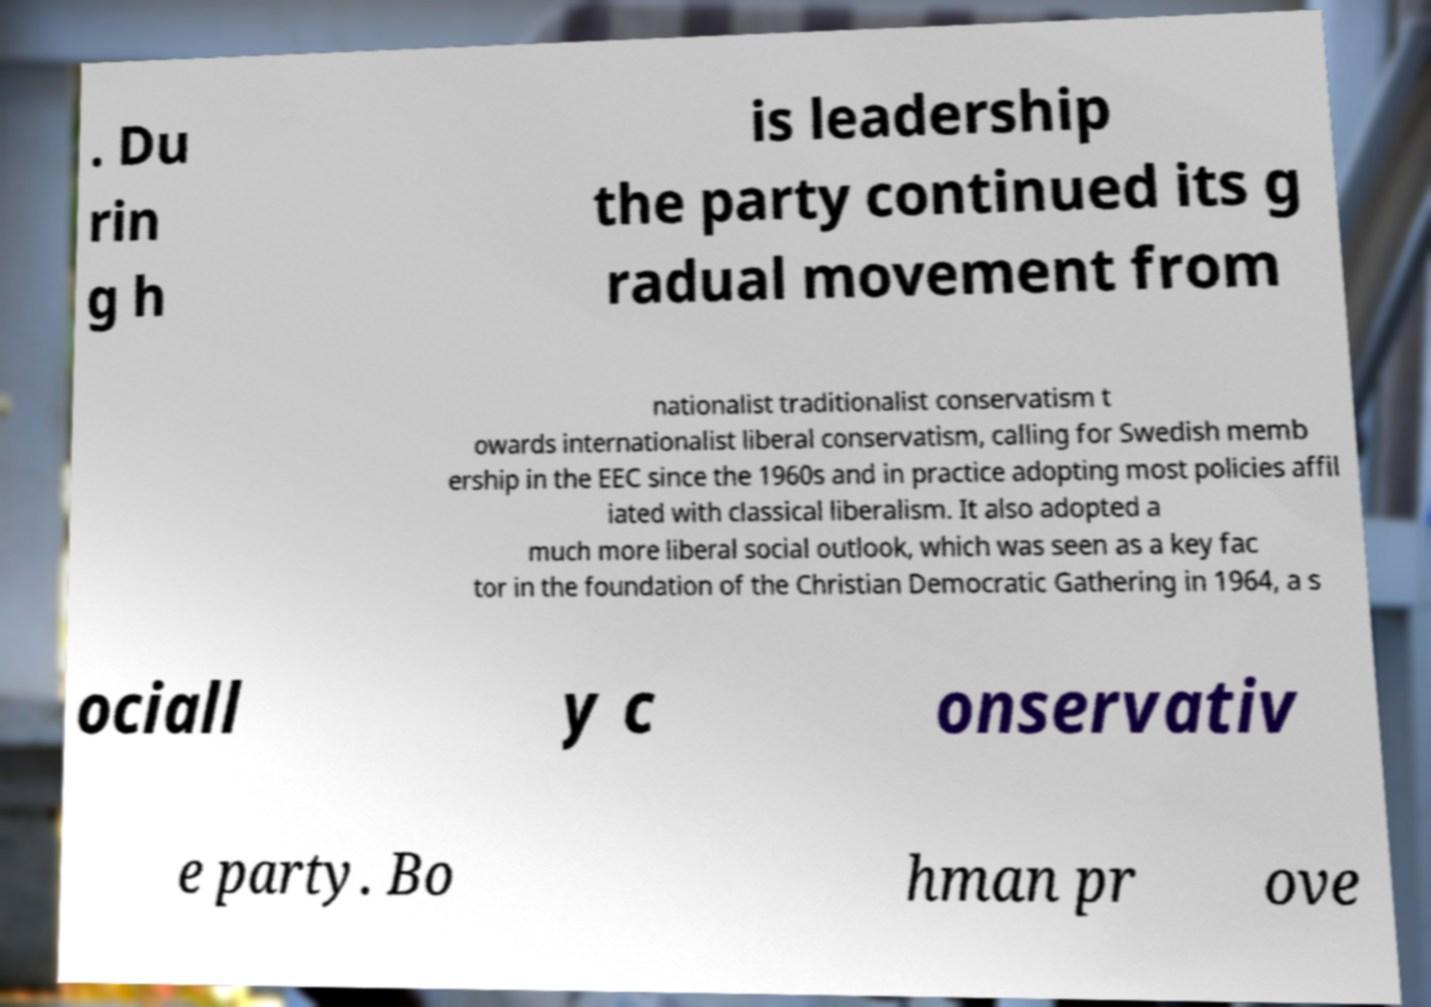Can you accurately transcribe the text from the provided image for me? . Du rin g h is leadership the party continued its g radual movement from nationalist traditionalist conservatism t owards internationalist liberal conservatism, calling for Swedish memb ership in the EEC since the 1960s and in practice adopting most policies affil iated with classical liberalism. It also adopted a much more liberal social outlook, which was seen as a key fac tor in the foundation of the Christian Democratic Gathering in 1964, a s ociall y c onservativ e party. Bo hman pr ove 